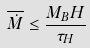<formula> <loc_0><loc_0><loc_500><loc_500>\overline { \dot { M } } \leq \frac { M _ { B } H } { \tau _ { H } }</formula> 